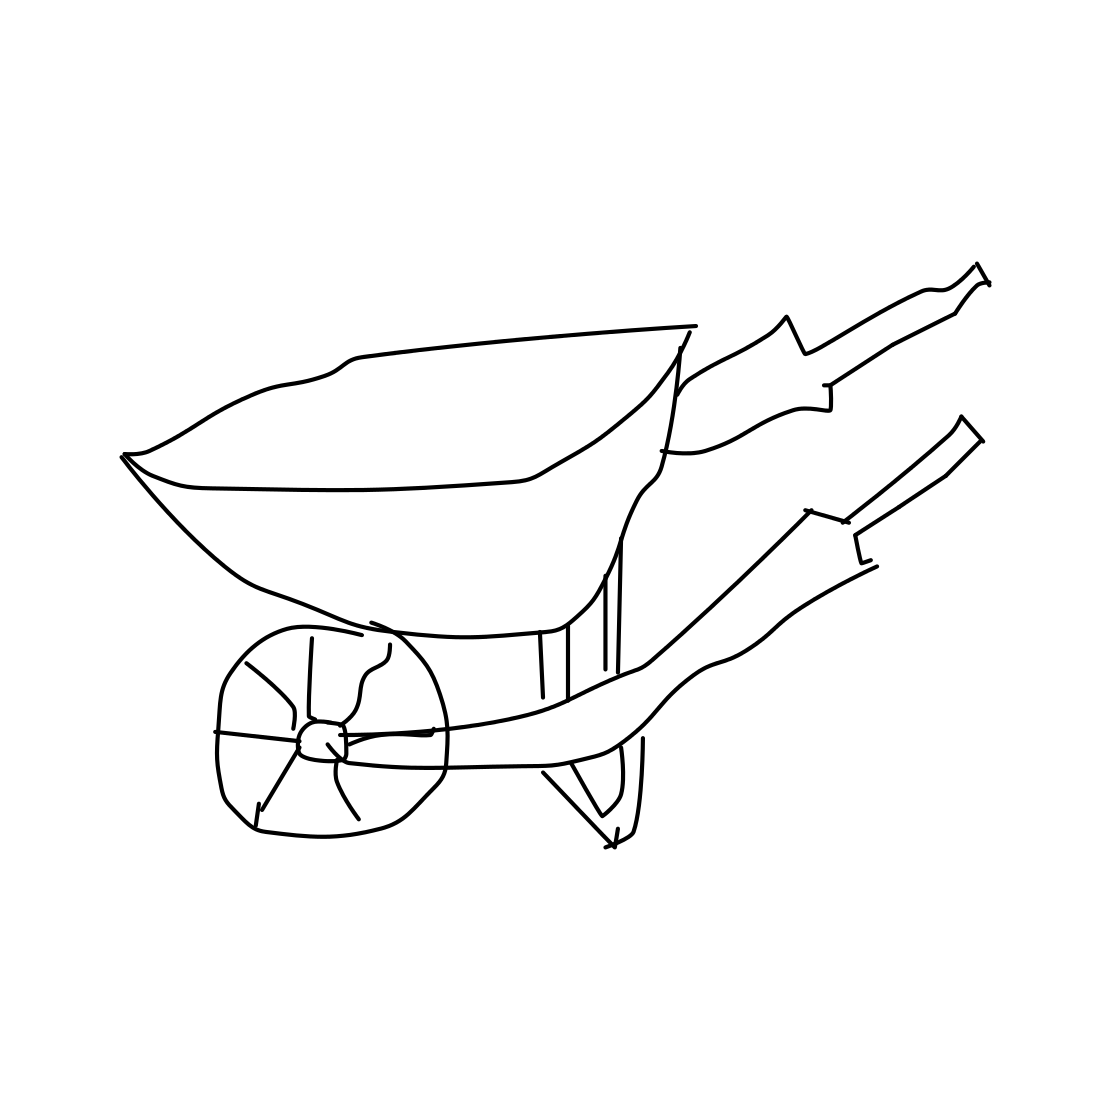Is this a wheelbarrow in the image? Yes 